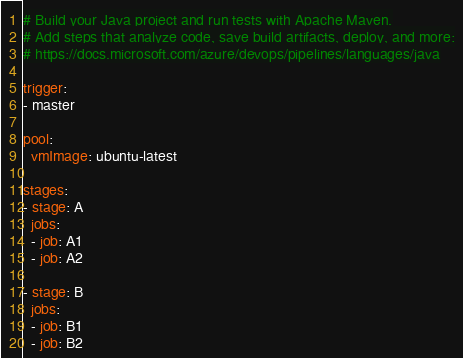Convert code to text. <code><loc_0><loc_0><loc_500><loc_500><_YAML_># Build your Java project and run tests with Apache Maven.
# Add steps that analyze code, save build artifacts, deploy, and more:
# https://docs.microsoft.com/azure/devops/pipelines/languages/java

trigger:
- master

pool:
  vmImage: ubuntu-latest

stages:
- stage: A
  jobs:
  - job: A1
  - job: A2

- stage: B
  jobs:
  - job: B1
  - job: B2
</code> 